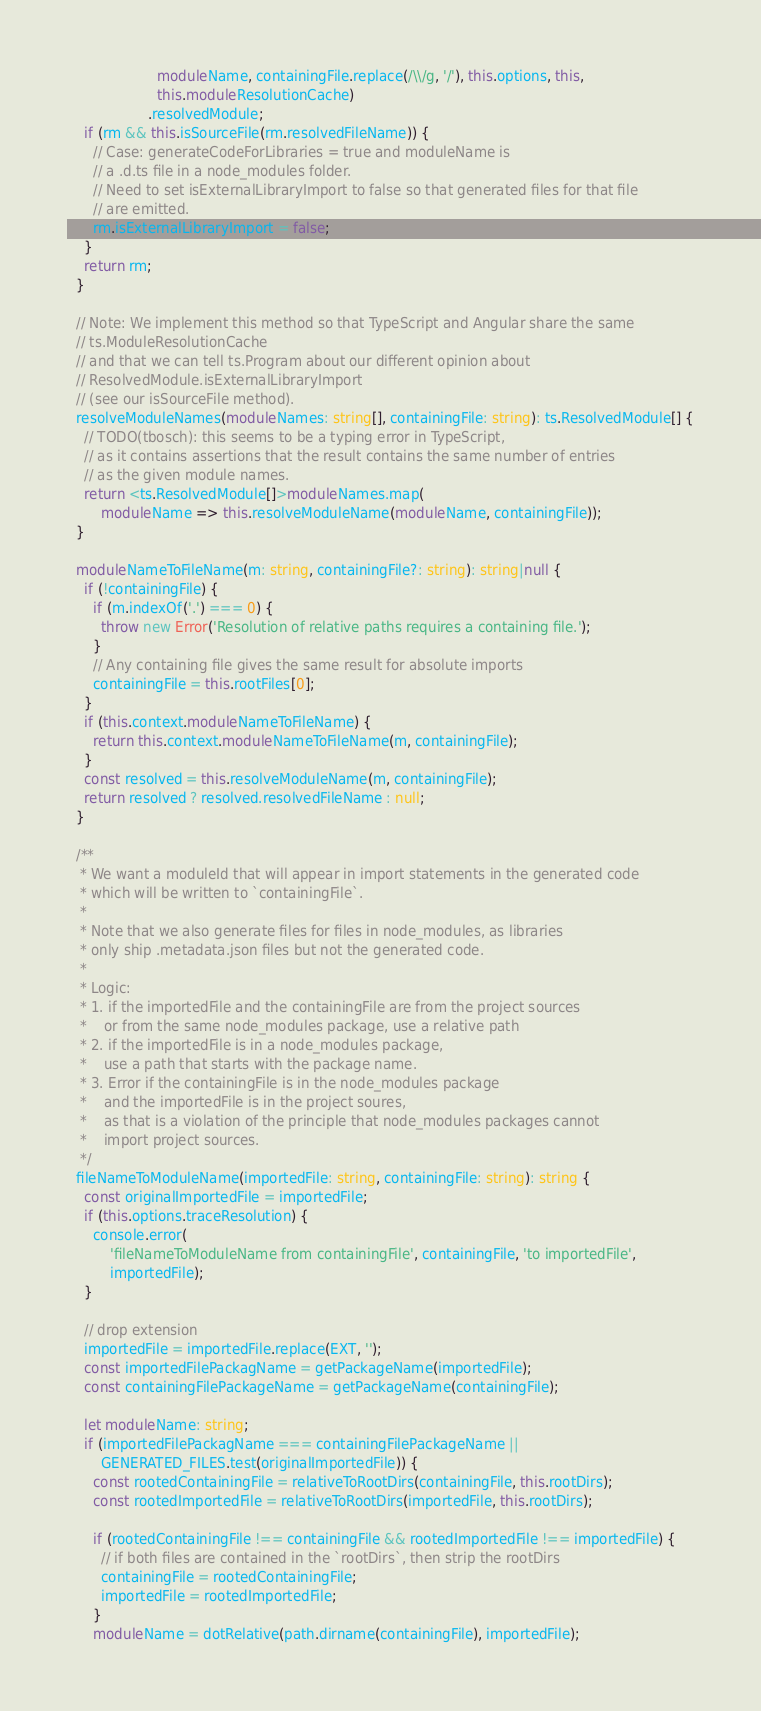<code> <loc_0><loc_0><loc_500><loc_500><_TypeScript_>                     moduleName, containingFile.replace(/\\/g, '/'), this.options, this,
                     this.moduleResolutionCache)
                   .resolvedModule;
    if (rm && this.isSourceFile(rm.resolvedFileName)) {
      // Case: generateCodeForLibraries = true and moduleName is
      // a .d.ts file in a node_modules folder.
      // Need to set isExternalLibraryImport to false so that generated files for that file
      // are emitted.
      rm.isExternalLibraryImport = false;
    }
    return rm;
  }

  // Note: We implement this method so that TypeScript and Angular share the same
  // ts.ModuleResolutionCache
  // and that we can tell ts.Program about our different opinion about
  // ResolvedModule.isExternalLibraryImport
  // (see our isSourceFile method).
  resolveModuleNames(moduleNames: string[], containingFile: string): ts.ResolvedModule[] {
    // TODO(tbosch): this seems to be a typing error in TypeScript,
    // as it contains assertions that the result contains the same number of entries
    // as the given module names.
    return <ts.ResolvedModule[]>moduleNames.map(
        moduleName => this.resolveModuleName(moduleName, containingFile));
  }

  moduleNameToFileName(m: string, containingFile?: string): string|null {
    if (!containingFile) {
      if (m.indexOf('.') === 0) {
        throw new Error('Resolution of relative paths requires a containing file.');
      }
      // Any containing file gives the same result for absolute imports
      containingFile = this.rootFiles[0];
    }
    if (this.context.moduleNameToFileName) {
      return this.context.moduleNameToFileName(m, containingFile);
    }
    const resolved = this.resolveModuleName(m, containingFile);
    return resolved ? resolved.resolvedFileName : null;
  }

  /**
   * We want a moduleId that will appear in import statements in the generated code
   * which will be written to `containingFile`.
   *
   * Note that we also generate files for files in node_modules, as libraries
   * only ship .metadata.json files but not the generated code.
   *
   * Logic:
   * 1. if the importedFile and the containingFile are from the project sources
   *    or from the same node_modules package, use a relative path
   * 2. if the importedFile is in a node_modules package,
   *    use a path that starts with the package name.
   * 3. Error if the containingFile is in the node_modules package
   *    and the importedFile is in the project soures,
   *    as that is a violation of the principle that node_modules packages cannot
   *    import project sources.
   */
  fileNameToModuleName(importedFile: string, containingFile: string): string {
    const originalImportedFile = importedFile;
    if (this.options.traceResolution) {
      console.error(
          'fileNameToModuleName from containingFile', containingFile, 'to importedFile',
          importedFile);
    }

    // drop extension
    importedFile = importedFile.replace(EXT, '');
    const importedFilePackagName = getPackageName(importedFile);
    const containingFilePackageName = getPackageName(containingFile);

    let moduleName: string;
    if (importedFilePackagName === containingFilePackageName ||
        GENERATED_FILES.test(originalImportedFile)) {
      const rootedContainingFile = relativeToRootDirs(containingFile, this.rootDirs);
      const rootedImportedFile = relativeToRootDirs(importedFile, this.rootDirs);

      if (rootedContainingFile !== containingFile && rootedImportedFile !== importedFile) {
        // if both files are contained in the `rootDirs`, then strip the rootDirs
        containingFile = rootedContainingFile;
        importedFile = rootedImportedFile;
      }
      moduleName = dotRelative(path.dirname(containingFile), importedFile);</code> 